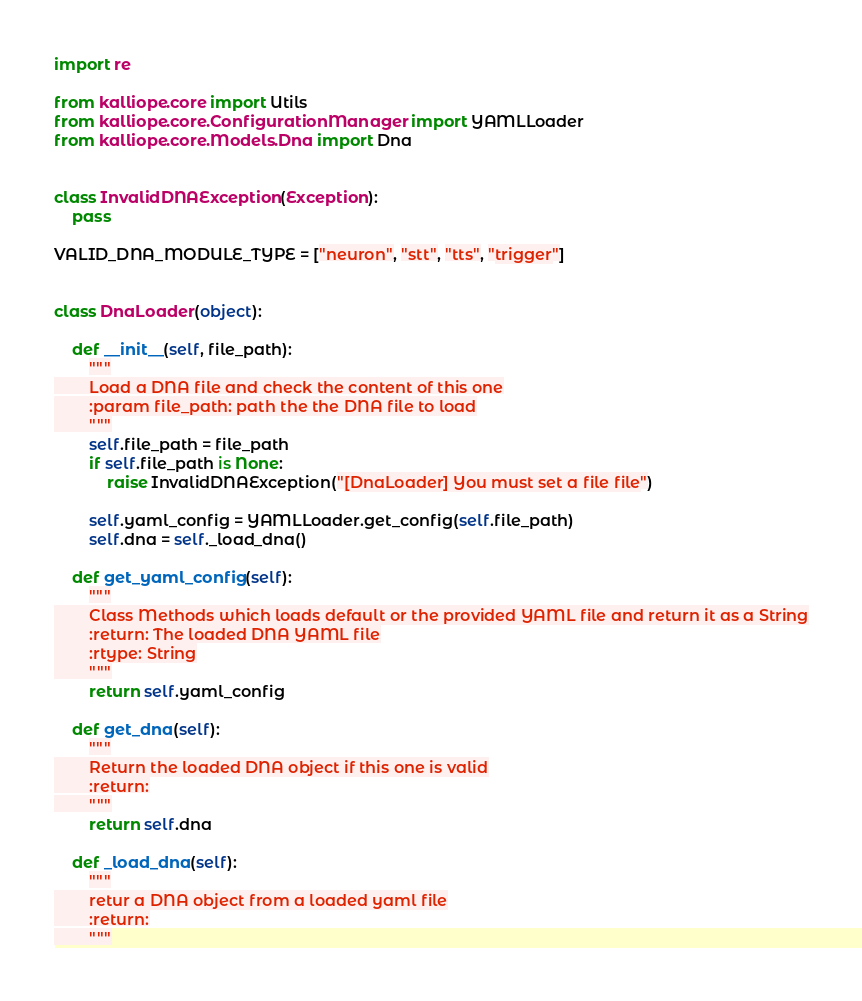<code> <loc_0><loc_0><loc_500><loc_500><_Python_>import re

from kalliope.core import Utils
from kalliope.core.ConfigurationManager import YAMLLoader
from kalliope.core.Models.Dna import Dna


class InvalidDNAException(Exception):
    pass

VALID_DNA_MODULE_TYPE = ["neuron", "stt", "tts", "trigger"]


class DnaLoader(object):

    def __init__(self, file_path):
        """
        Load a DNA file and check the content of this one
        :param file_path: path the the DNA file to load
        """
        self.file_path = file_path
        if self.file_path is None:
            raise InvalidDNAException("[DnaLoader] You must set a file file")

        self.yaml_config = YAMLLoader.get_config(self.file_path)
        self.dna = self._load_dna()

    def get_yaml_config(self):
        """
        Class Methods which loads default or the provided YAML file and return it as a String
        :return: The loaded DNA YAML file
        :rtype: String
        """
        return self.yaml_config

    def get_dna(self):
        """
        Return the loaded DNA object if this one is valid
        :return:
        """
        return self.dna

    def _load_dna(self):
        """
        retur a DNA object from a loaded yaml file
        :return:
        """</code> 